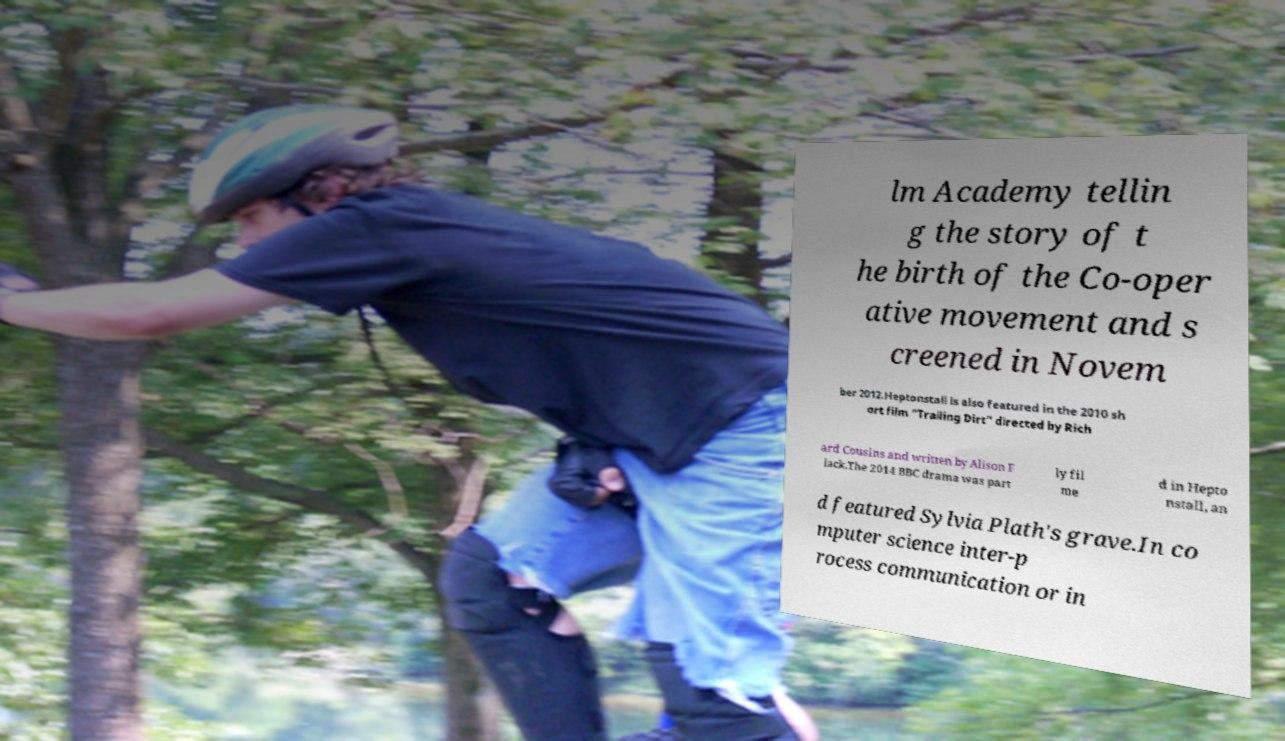Can you read and provide the text displayed in the image?This photo seems to have some interesting text. Can you extract and type it out for me? lm Academy tellin g the story of t he birth of the Co-oper ative movement and s creened in Novem ber 2012.Heptonstall is also featured in the 2010 sh ort film "Trailing Dirt" directed by Rich ard Cousins and written by Alison F lack.The 2014 BBC drama was part ly fil me d in Hepto nstall, an d featured Sylvia Plath's grave.In co mputer science inter-p rocess communication or in 